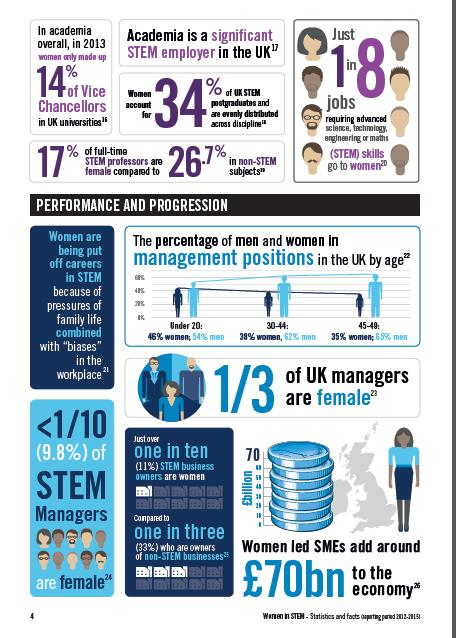Draw attention to some important aspects in this diagram. In the UK, a significant percentage of men in the age group of 30-44 hold management positions, with 62% of them occupying such positions. In the UK, approximately 46% of women under the age of 20 hold management positions. According to a recent survey, 38% of women in the age group of 30-44 in the UK hold management positions. 